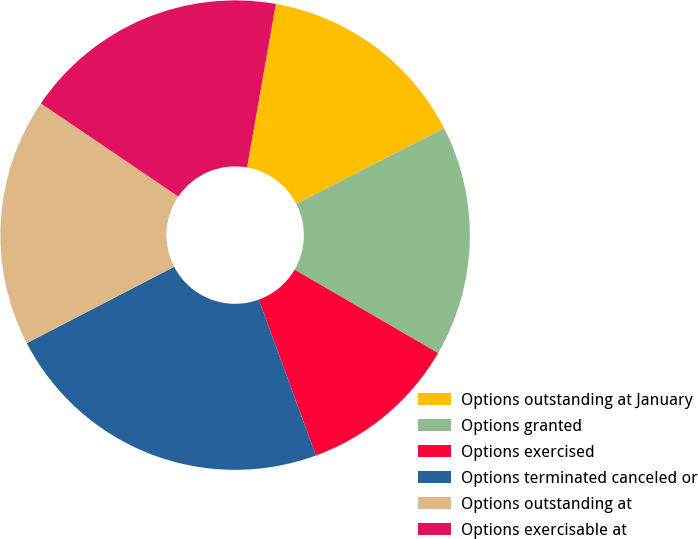<chart> <loc_0><loc_0><loc_500><loc_500><pie_chart><fcel>Options outstanding at January<fcel>Options granted<fcel>Options exercised<fcel>Options terminated canceled or<fcel>Options outstanding at<fcel>Options exercisable at<nl><fcel>14.71%<fcel>15.9%<fcel>11.03%<fcel>22.98%<fcel>17.1%<fcel>18.29%<nl></chart> 